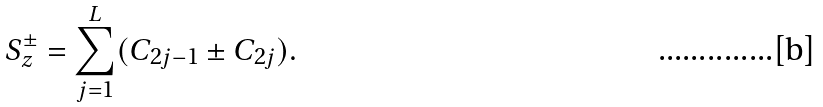Convert formula to latex. <formula><loc_0><loc_0><loc_500><loc_500>S _ { z } ^ { \pm } = \sum _ { j = 1 } ^ { L } ( C _ { 2 j - 1 } \pm C _ { 2 j } ) .</formula> 